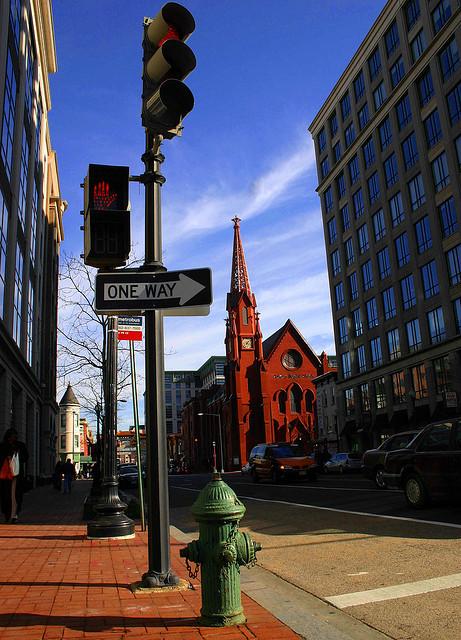Overcast or sunny?
Give a very brief answer. Sunny. What way is the one way sign pointing?
Give a very brief answer. Right. What color is the hydrant?
Concise answer only. Green. What kind of building has the tall spire?
Keep it brief. Church. Is it daytime?
Keep it brief. Yes. What time is it according to the clock?
Short answer required. Noon. 